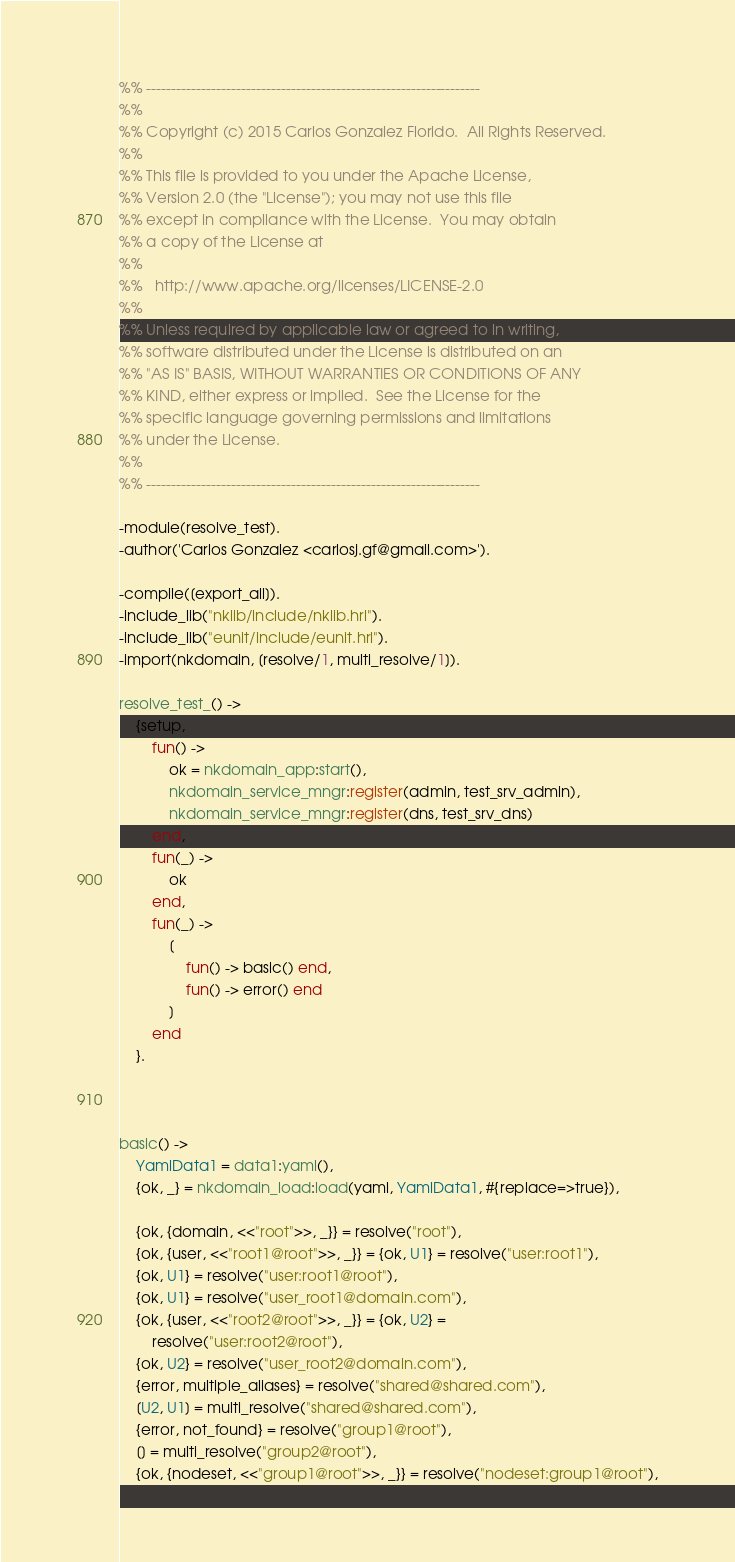Convert code to text. <code><loc_0><loc_0><loc_500><loc_500><_Erlang_>%% -------------------------------------------------------------------
%%
%% Copyright (c) 2015 Carlos Gonzalez Florido.  All Rights Reserved.
%%
%% This file is provided to you under the Apache License,
%% Version 2.0 (the "License"); you may not use this file
%% except in compliance with the License.  You may obtain
%% a copy of the License at
%%
%%   http://www.apache.org/licenses/LICENSE-2.0
%%
%% Unless required by applicable law or agreed to in writing,
%% software distributed under the License is distributed on an
%% "AS IS" BASIS, WITHOUT WARRANTIES OR CONDITIONS OF ANY
%% KIND, either express or implied.  See the License for the
%% specific language governing permissions and limitations
%% under the License.
%%
%% -------------------------------------------------------------------

-module(resolve_test).
-author('Carlos Gonzalez <carlosj.gf@gmail.com>').

-compile([export_all]).
-include_lib("nklib/include/nklib.hrl").
-include_lib("eunit/include/eunit.hrl").
-import(nkdomain, [resolve/1, multi_resolve/1]).

resolve_test_() ->
  	{setup, 
    	fun() -> 
    		ok = nkdomain_app:start(),
            nkdomain_service_mngr:register(admin, test_srv_admin),
            nkdomain_service_mngr:register(dns, test_srv_dns)
        end,
		fun(_) -> 
			ok 
		end,
	    fun(_) ->
		    [
				fun() -> basic() end,
                fun() -> error() end
			]
		end
  	}.



basic() ->
    YamlData1 = data1:yaml(),
    {ok, _} = nkdomain_load:load(yaml, YamlData1, #{replace=>true}),

    {ok, {domain, <<"root">>, _}} = resolve("root"),
    {ok, {user, <<"root1@root">>, _}} = {ok, U1} = resolve("user:root1"),
    {ok, U1} = resolve("user:root1@root"),
    {ok, U1} = resolve("user_root1@domain.com"),
    {ok, {user, <<"root2@root">>, _}} = {ok, U2} = 
        resolve("user:root2@root"),
    {ok, U2} = resolve("user_root2@domain.com"),
    {error, multiple_aliases} = resolve("shared@shared.com"),
    [U2, U1] = multi_resolve("shared@shared.com"),
    {error, not_found} = resolve("group1@root"),
    [] = multi_resolve("group2@root"),
    {ok, {nodeset, <<"group1@root">>, _}} = resolve("nodeset:group1@root"),</code> 